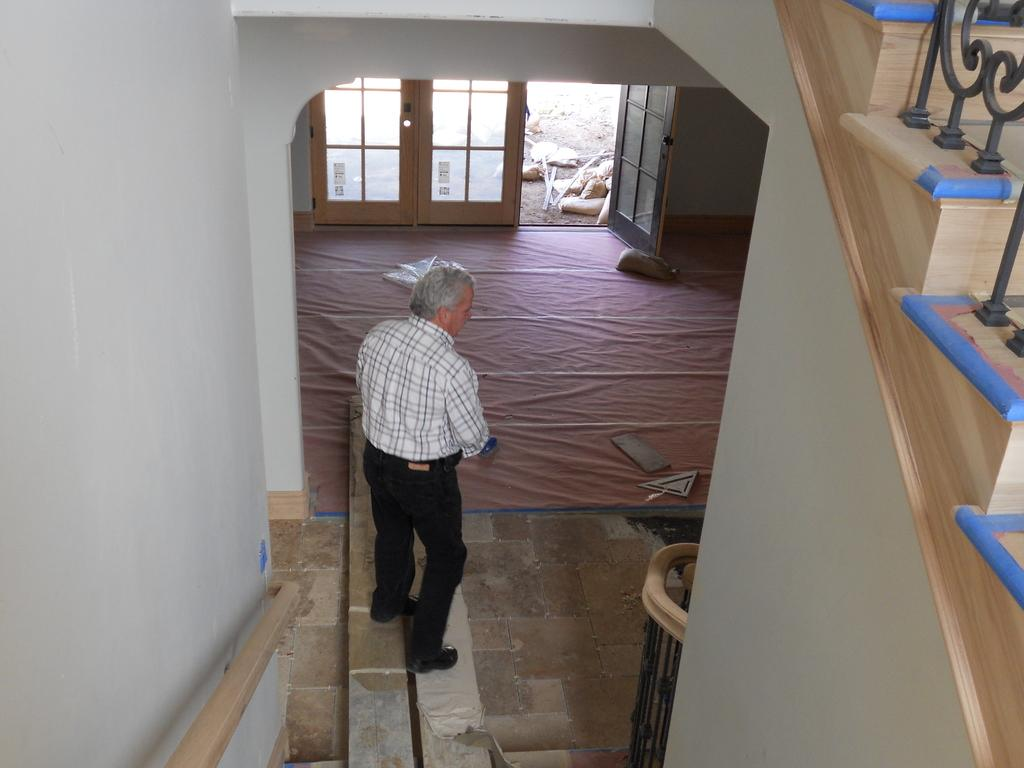Where was the image taken? The image was taken inside a building. What can be seen at the top of the image? There is a door at the top of the image. What architectural feature is on the right side of the image? There are stairs on the right side of the image. Who is present in the middle of the image? There is a man standing in the middle of the image. What type of material is present in large quantities in the image? There are many cardboards present in the image. What type of fowl can be seen flying in the image? There are no fowl present in the image; it is taken inside a building with a man, stairs, a door, and cardboards. 